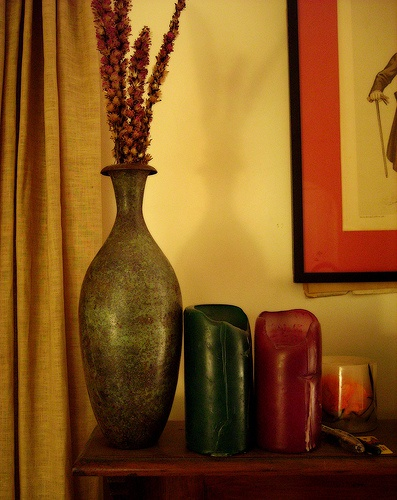Describe the objects in this image and their specific colors. I can see potted plant in maroon, black, and olive tones, vase in maroon, olive, and black tones, vase in maroon, black, and olive tones, vase in maroon, black, and brown tones, and cup in maroon, black, and brown tones in this image. 